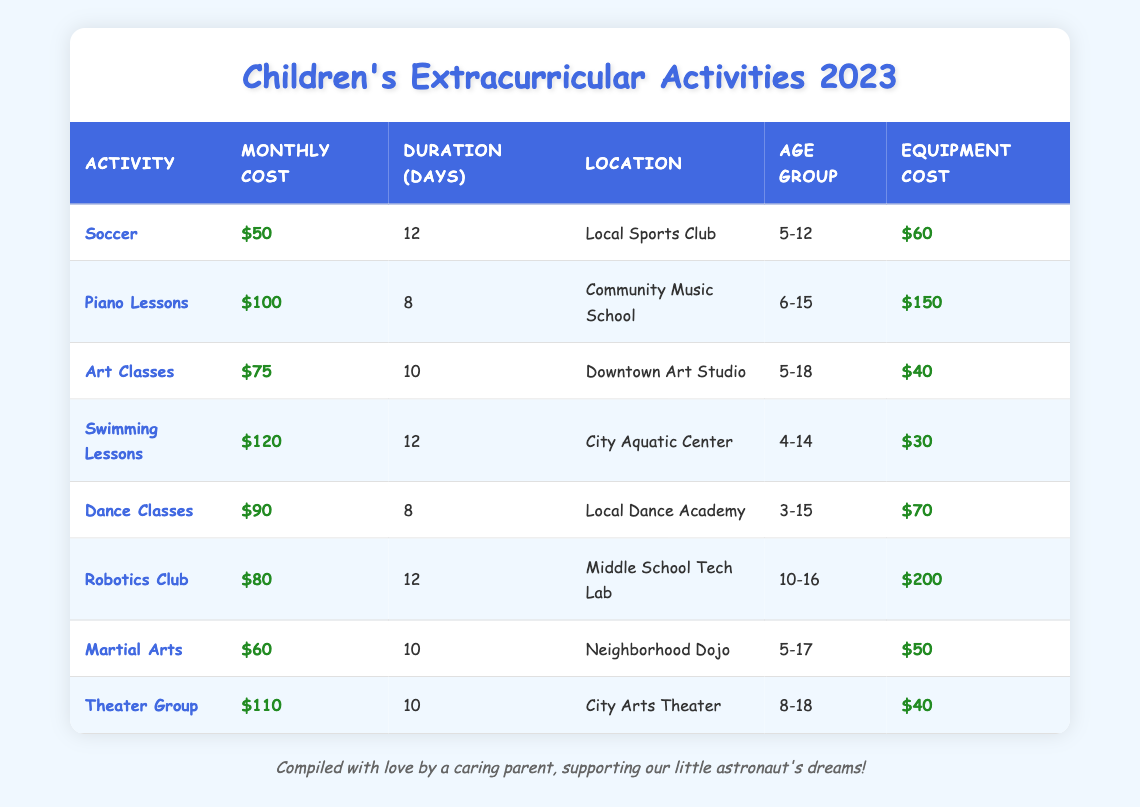What is the monthly cost of Soccer lessons? The table shows that the monthly cost of Soccer lessons is listed under the "Monthly Cost" column for "Soccer" activity as $50.
Answer: $50 Which activity has the highest equipment cost? To determine which activity has the highest equipment cost, we compare the "Equipment Cost" values from all activities. Robotics Club has the highest equipment cost at $200.
Answer: Robotics Club How many days do Dance Classes occur per month? From the table, the "Duration (Days)" column for Dance Classes shows that they occur for 8 days per month.
Answer: 8 days What is the total monthly cost of participating in both Art Classes and Swimming Lessons? To find the total monthly cost for both activities, we add the monthly costs from the table: Art Classes ($75) + Swimming Lessons ($120) = $195.
Answer: $195 Is it true that all activities listed are for children under 18 years old? We check the "Age Group" column, and we find that all activities cater to children up to 18 years old or younger, so this statement is true.
Answer: Yes Which activity is for the youngest age group? The activity with the youngest age group listed in the "Age Group" column is Dance Classes, which accommodates children from ages 3-15.
Answer: Dance Classes What is the average monthly cost of all the activities listed? To find the average monthly cost, we sum the monthly costs of all activities: $50 + $100 + $75 + $120 + $90 + $80 + $60 + $110 = $685. There are 8 activities, so the average is $685 / 8 = $85.625, which we round to approximately $86.
Answer: $86 Which location offers Swimming Lessons? The "Location" column indicates that Swimming Lessons are offered at the City Aquatic Center.
Answer: City Aquatic Center How many activities have a monthly cost of $80 or less? We check the monthly costs for each activity, and we find that Soccer ($50), Martial Arts ($60), and Robotics Club ($80) are $80 or less. Thus, there are 3 activities that meet this criteria.
Answer: 3 